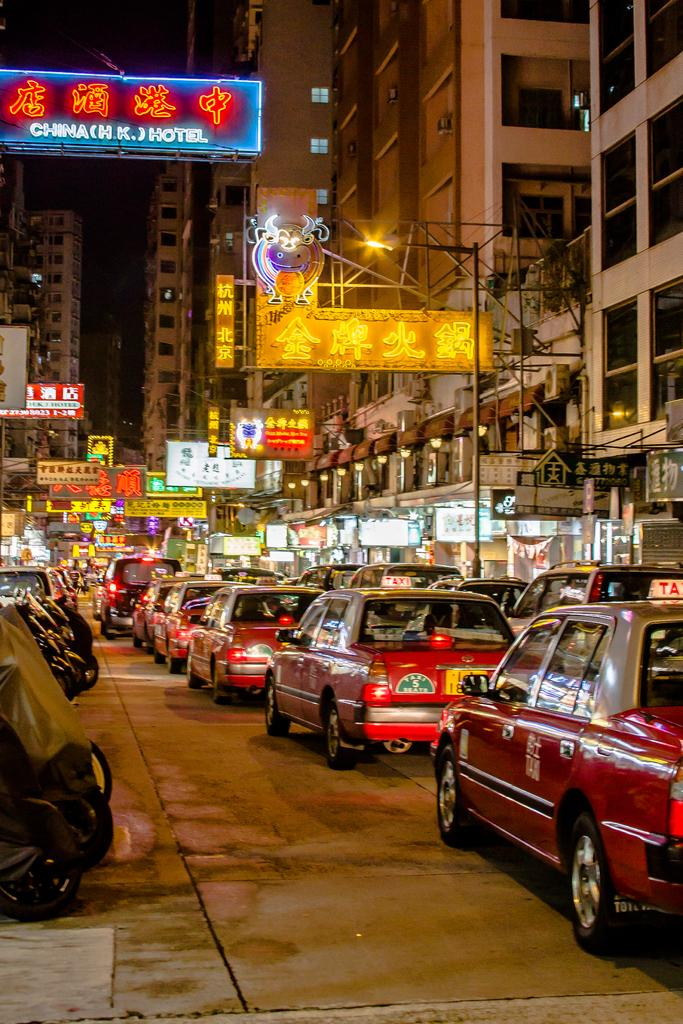Provide a one-sentence caption for the provided image. A long line of taxis are bumper to bumper on a street adorned with neon business signs, such as hotels. 